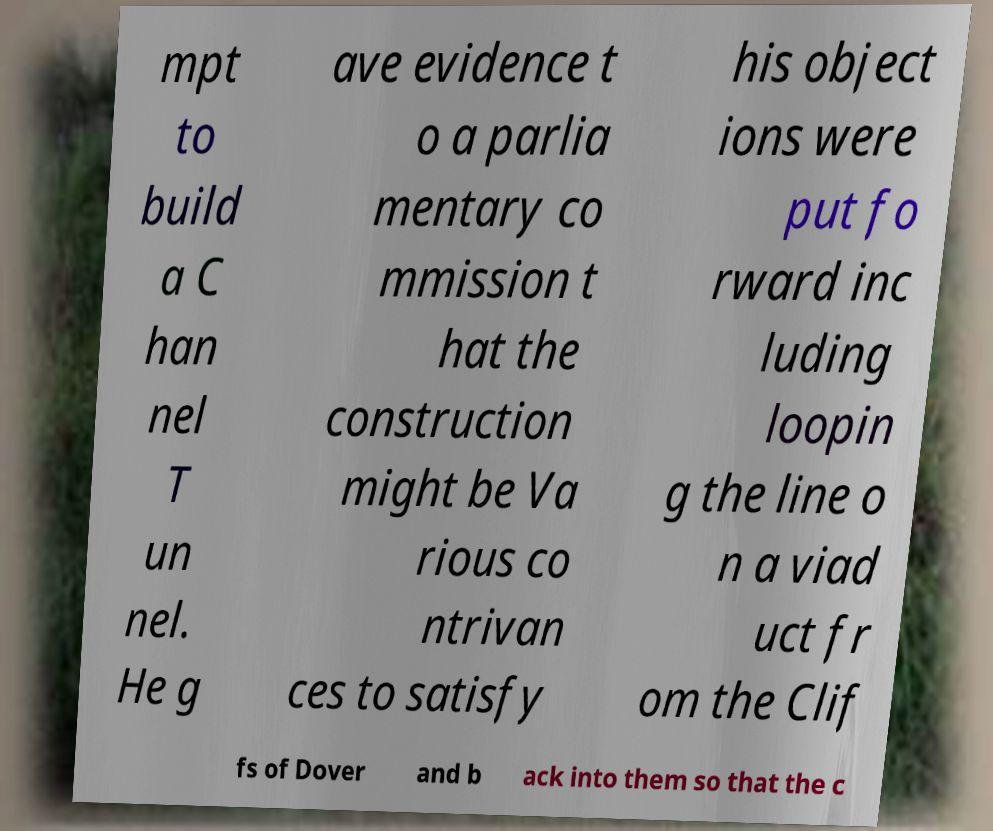What messages or text are displayed in this image? I need them in a readable, typed format. mpt to build a C han nel T un nel. He g ave evidence t o a parlia mentary co mmission t hat the construction might be Va rious co ntrivan ces to satisfy his object ions were put fo rward inc luding loopin g the line o n a viad uct fr om the Clif fs of Dover and b ack into them so that the c 